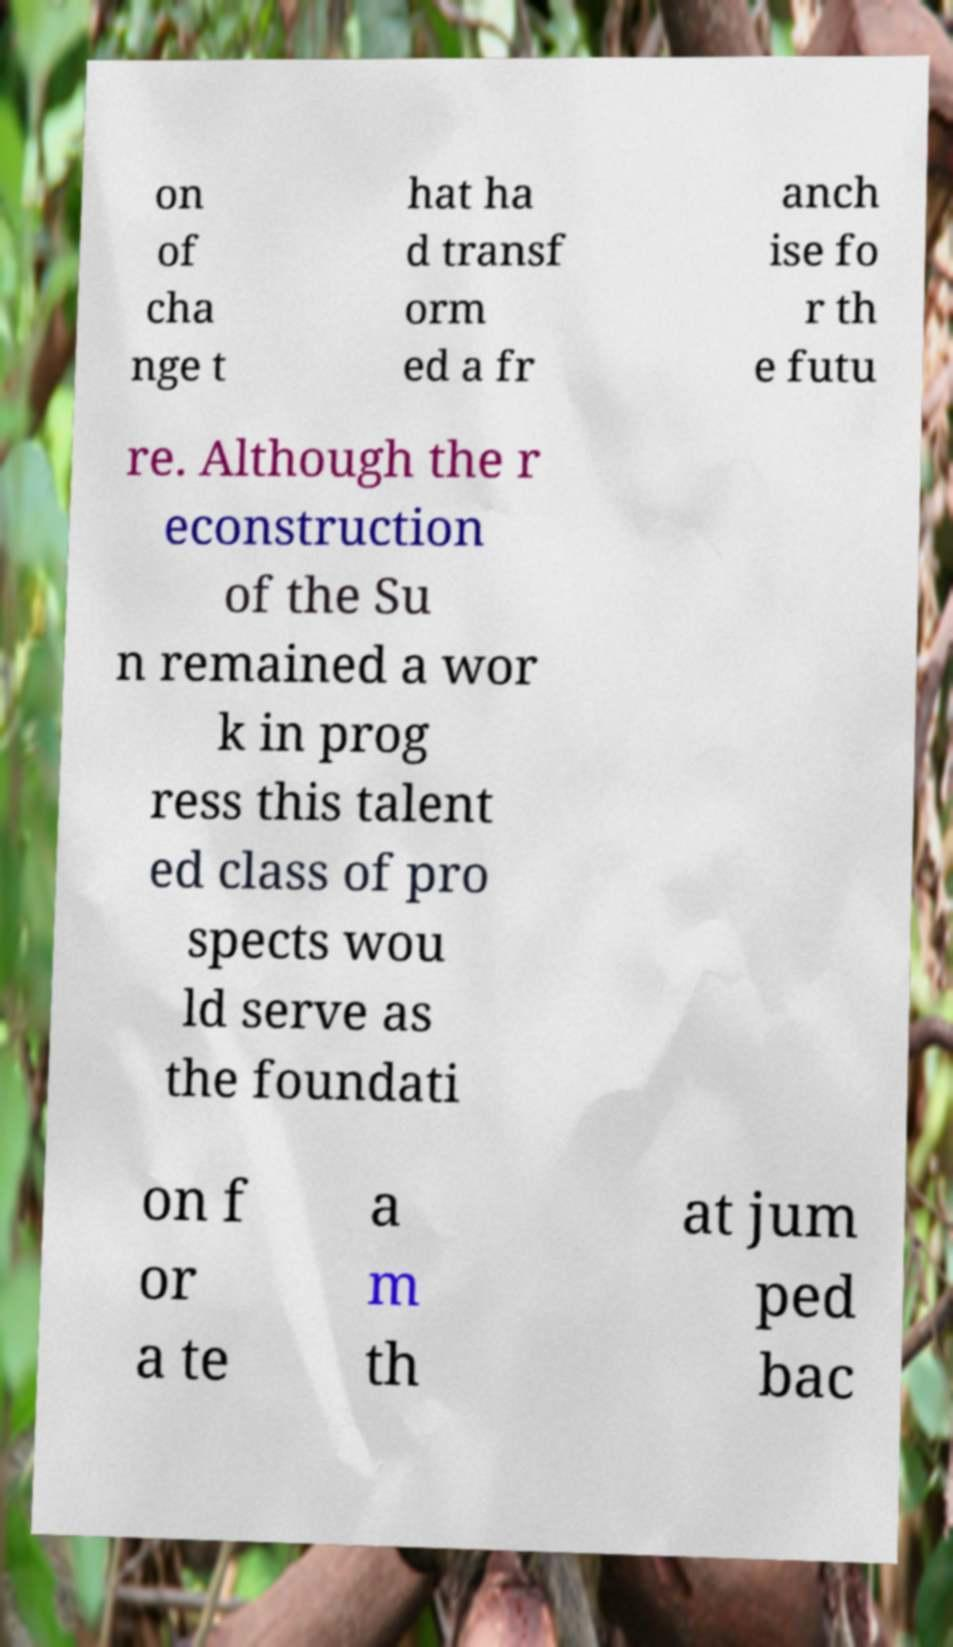I need the written content from this picture converted into text. Can you do that? on of cha nge t hat ha d transf orm ed a fr anch ise fo r th e futu re. Although the r econstruction of the Su n remained a wor k in prog ress this talent ed class of pro spects wou ld serve as the foundati on f or a te a m th at jum ped bac 